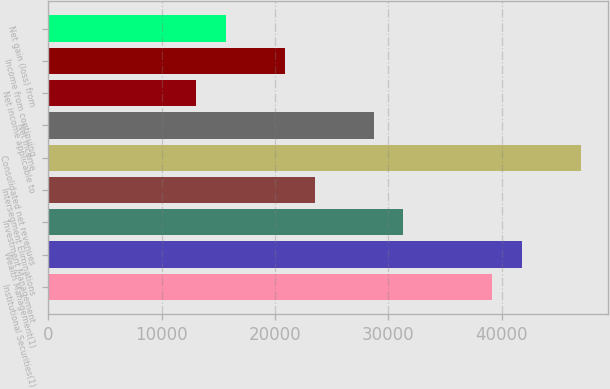<chart> <loc_0><loc_0><loc_500><loc_500><bar_chart><fcel>Institutional Securities(1)<fcel>Wealth Management(1)<fcel>Investment Management<fcel>Intersegment Eliminations<fcel>Consolidated net revenues<fcel>Net income<fcel>Net income applicable to<fcel>Income from continuing<fcel>Net gain (loss) from<nl><fcel>39153<fcel>41763.2<fcel>31322.4<fcel>23491.8<fcel>46983.6<fcel>28712.2<fcel>13051<fcel>20881.6<fcel>15661.2<nl></chart> 